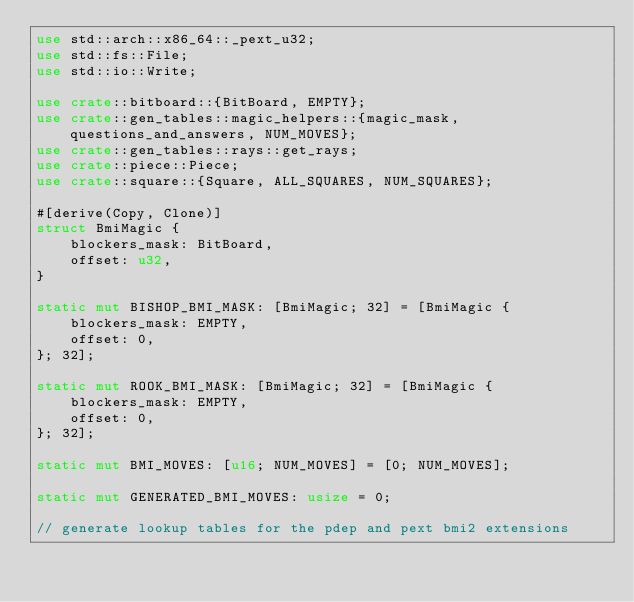Convert code to text. <code><loc_0><loc_0><loc_500><loc_500><_Rust_>use std::arch::x86_64::_pext_u32;
use std::fs::File;
use std::io::Write;

use crate::bitboard::{BitBoard, EMPTY};
use crate::gen_tables::magic_helpers::{magic_mask, questions_and_answers, NUM_MOVES};
use crate::gen_tables::rays::get_rays;
use crate::piece::Piece;
use crate::square::{Square, ALL_SQUARES, NUM_SQUARES};

#[derive(Copy, Clone)]
struct BmiMagic {
    blockers_mask: BitBoard,
    offset: u32,
}

static mut BISHOP_BMI_MASK: [BmiMagic; 32] = [BmiMagic {
    blockers_mask: EMPTY,
    offset: 0,
}; 32];

static mut ROOK_BMI_MASK: [BmiMagic; 32] = [BmiMagic {
    blockers_mask: EMPTY,
    offset: 0,
}; 32];

static mut BMI_MOVES: [u16; NUM_MOVES] = [0; NUM_MOVES];

static mut GENERATED_BMI_MOVES: usize = 0;

// generate lookup tables for the pdep and pext bmi2 extensions</code> 